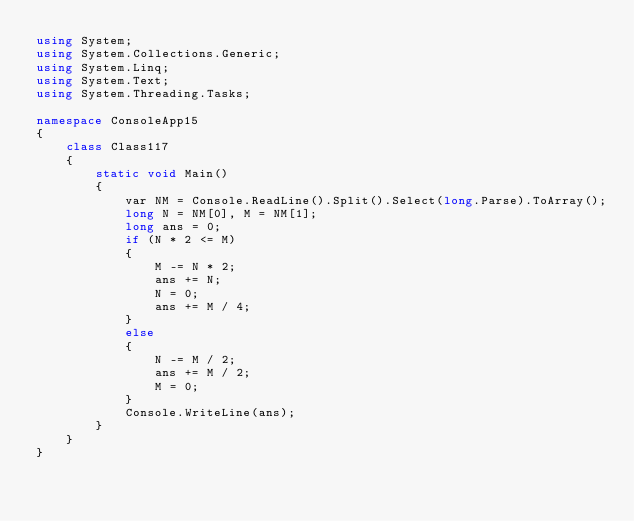<code> <loc_0><loc_0><loc_500><loc_500><_C#_>using System;
using System.Collections.Generic;
using System.Linq;
using System.Text;
using System.Threading.Tasks;

namespace ConsoleApp15
{
    class Class117
    {
        static void Main()
        {
            var NM = Console.ReadLine().Split().Select(long.Parse).ToArray();
            long N = NM[0], M = NM[1];
            long ans = 0;
            if (N * 2 <= M)
            {
                M -= N * 2;
                ans += N;
                N = 0;
                ans += M / 4;
            }
            else
            {
                N -= M / 2;
                ans += M / 2;
                M = 0;
            }
            Console.WriteLine(ans);
        }
    }
}
</code> 